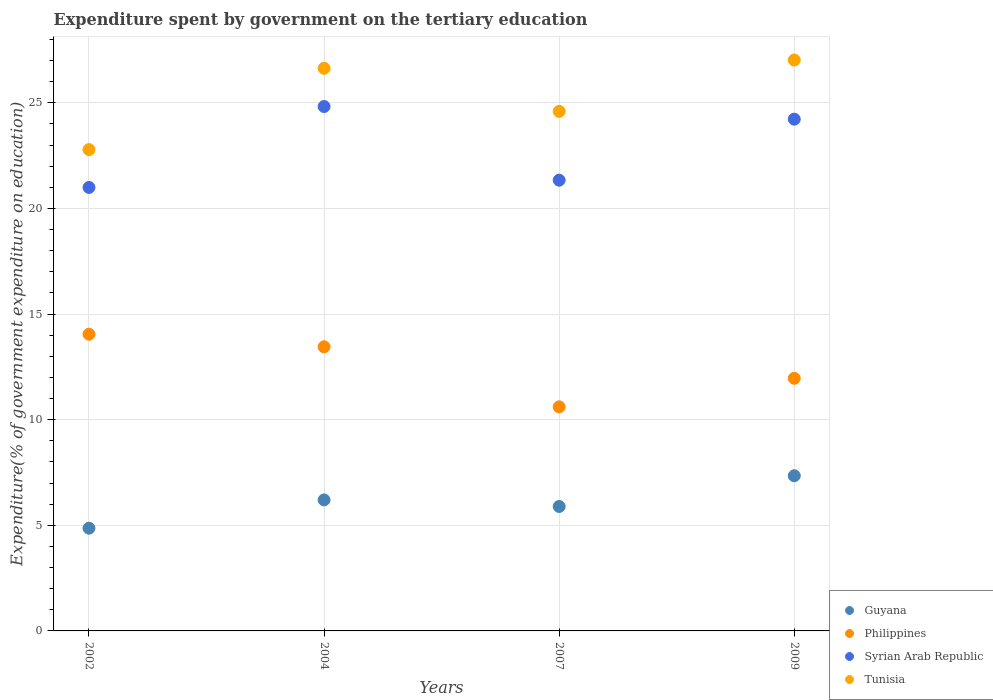How many different coloured dotlines are there?
Ensure brevity in your answer.  4. Is the number of dotlines equal to the number of legend labels?
Provide a succinct answer. Yes. What is the expenditure spent by government on the tertiary education in Philippines in 2002?
Offer a very short reply. 14.05. Across all years, what is the maximum expenditure spent by government on the tertiary education in Philippines?
Offer a very short reply. 14.05. Across all years, what is the minimum expenditure spent by government on the tertiary education in Philippines?
Keep it short and to the point. 10.61. What is the total expenditure spent by government on the tertiary education in Tunisia in the graph?
Keep it short and to the point. 101.03. What is the difference between the expenditure spent by government on the tertiary education in Tunisia in 2002 and that in 2004?
Your answer should be very brief. -3.85. What is the difference between the expenditure spent by government on the tertiary education in Tunisia in 2002 and the expenditure spent by government on the tertiary education in Syrian Arab Republic in 2009?
Provide a short and direct response. -1.44. What is the average expenditure spent by government on the tertiary education in Tunisia per year?
Your response must be concise. 25.26. In the year 2002, what is the difference between the expenditure spent by government on the tertiary education in Guyana and expenditure spent by government on the tertiary education in Philippines?
Ensure brevity in your answer.  -9.18. In how many years, is the expenditure spent by government on the tertiary education in Syrian Arab Republic greater than 16 %?
Make the answer very short. 4. What is the ratio of the expenditure spent by government on the tertiary education in Tunisia in 2002 to that in 2007?
Your answer should be very brief. 0.93. Is the difference between the expenditure spent by government on the tertiary education in Guyana in 2007 and 2009 greater than the difference between the expenditure spent by government on the tertiary education in Philippines in 2007 and 2009?
Ensure brevity in your answer.  No. What is the difference between the highest and the second highest expenditure spent by government on the tertiary education in Guyana?
Offer a very short reply. 1.14. What is the difference between the highest and the lowest expenditure spent by government on the tertiary education in Tunisia?
Your response must be concise. 4.24. In how many years, is the expenditure spent by government on the tertiary education in Philippines greater than the average expenditure spent by government on the tertiary education in Philippines taken over all years?
Offer a very short reply. 2. Is the sum of the expenditure spent by government on the tertiary education in Philippines in 2002 and 2007 greater than the maximum expenditure spent by government on the tertiary education in Tunisia across all years?
Keep it short and to the point. No. Is the expenditure spent by government on the tertiary education in Guyana strictly less than the expenditure spent by government on the tertiary education in Syrian Arab Republic over the years?
Your response must be concise. Yes. How many dotlines are there?
Your response must be concise. 4. Are the values on the major ticks of Y-axis written in scientific E-notation?
Offer a terse response. No. Does the graph contain grids?
Offer a terse response. Yes. How are the legend labels stacked?
Your answer should be compact. Vertical. What is the title of the graph?
Offer a very short reply. Expenditure spent by government on the tertiary education. Does "Burkina Faso" appear as one of the legend labels in the graph?
Offer a terse response. No. What is the label or title of the Y-axis?
Keep it short and to the point. Expenditure(% of government expenditure on education). What is the Expenditure(% of government expenditure on education) of Guyana in 2002?
Give a very brief answer. 4.86. What is the Expenditure(% of government expenditure on education) in Philippines in 2002?
Provide a succinct answer. 14.05. What is the Expenditure(% of government expenditure on education) of Syrian Arab Republic in 2002?
Your response must be concise. 20.99. What is the Expenditure(% of government expenditure on education) in Tunisia in 2002?
Provide a short and direct response. 22.78. What is the Expenditure(% of government expenditure on education) in Guyana in 2004?
Offer a terse response. 6.2. What is the Expenditure(% of government expenditure on education) of Philippines in 2004?
Ensure brevity in your answer.  13.45. What is the Expenditure(% of government expenditure on education) in Syrian Arab Republic in 2004?
Your answer should be very brief. 24.82. What is the Expenditure(% of government expenditure on education) of Tunisia in 2004?
Your answer should be very brief. 26.63. What is the Expenditure(% of government expenditure on education) of Guyana in 2007?
Provide a succinct answer. 5.89. What is the Expenditure(% of government expenditure on education) of Philippines in 2007?
Provide a succinct answer. 10.61. What is the Expenditure(% of government expenditure on education) of Syrian Arab Republic in 2007?
Provide a succinct answer. 21.34. What is the Expenditure(% of government expenditure on education) in Tunisia in 2007?
Provide a short and direct response. 24.59. What is the Expenditure(% of government expenditure on education) of Guyana in 2009?
Offer a very short reply. 7.34. What is the Expenditure(% of government expenditure on education) of Philippines in 2009?
Provide a short and direct response. 11.96. What is the Expenditure(% of government expenditure on education) of Syrian Arab Republic in 2009?
Keep it short and to the point. 24.22. What is the Expenditure(% of government expenditure on education) of Tunisia in 2009?
Provide a short and direct response. 27.02. Across all years, what is the maximum Expenditure(% of government expenditure on education) of Guyana?
Your answer should be compact. 7.34. Across all years, what is the maximum Expenditure(% of government expenditure on education) of Philippines?
Offer a very short reply. 14.05. Across all years, what is the maximum Expenditure(% of government expenditure on education) in Syrian Arab Republic?
Your response must be concise. 24.82. Across all years, what is the maximum Expenditure(% of government expenditure on education) in Tunisia?
Your answer should be compact. 27.02. Across all years, what is the minimum Expenditure(% of government expenditure on education) of Guyana?
Your answer should be very brief. 4.86. Across all years, what is the minimum Expenditure(% of government expenditure on education) in Philippines?
Offer a terse response. 10.61. Across all years, what is the minimum Expenditure(% of government expenditure on education) of Syrian Arab Republic?
Provide a succinct answer. 20.99. Across all years, what is the minimum Expenditure(% of government expenditure on education) in Tunisia?
Keep it short and to the point. 22.78. What is the total Expenditure(% of government expenditure on education) of Guyana in the graph?
Make the answer very short. 24.3. What is the total Expenditure(% of government expenditure on education) in Philippines in the graph?
Make the answer very short. 50.06. What is the total Expenditure(% of government expenditure on education) of Syrian Arab Republic in the graph?
Your answer should be compact. 91.37. What is the total Expenditure(% of government expenditure on education) in Tunisia in the graph?
Ensure brevity in your answer.  101.03. What is the difference between the Expenditure(% of government expenditure on education) of Guyana in 2002 and that in 2004?
Provide a short and direct response. -1.34. What is the difference between the Expenditure(% of government expenditure on education) in Philippines in 2002 and that in 2004?
Make the answer very short. 0.6. What is the difference between the Expenditure(% of government expenditure on education) of Syrian Arab Republic in 2002 and that in 2004?
Your answer should be very brief. -3.83. What is the difference between the Expenditure(% of government expenditure on education) in Tunisia in 2002 and that in 2004?
Offer a very short reply. -3.85. What is the difference between the Expenditure(% of government expenditure on education) in Guyana in 2002 and that in 2007?
Your answer should be compact. -1.03. What is the difference between the Expenditure(% of government expenditure on education) of Philippines in 2002 and that in 2007?
Make the answer very short. 3.44. What is the difference between the Expenditure(% of government expenditure on education) in Syrian Arab Republic in 2002 and that in 2007?
Provide a succinct answer. -0.34. What is the difference between the Expenditure(% of government expenditure on education) in Tunisia in 2002 and that in 2007?
Make the answer very short. -1.81. What is the difference between the Expenditure(% of government expenditure on education) of Guyana in 2002 and that in 2009?
Offer a terse response. -2.48. What is the difference between the Expenditure(% of government expenditure on education) in Philippines in 2002 and that in 2009?
Your answer should be very brief. 2.09. What is the difference between the Expenditure(% of government expenditure on education) in Syrian Arab Republic in 2002 and that in 2009?
Give a very brief answer. -3.23. What is the difference between the Expenditure(% of government expenditure on education) in Tunisia in 2002 and that in 2009?
Offer a very short reply. -4.24. What is the difference between the Expenditure(% of government expenditure on education) in Guyana in 2004 and that in 2007?
Provide a succinct answer. 0.31. What is the difference between the Expenditure(% of government expenditure on education) in Philippines in 2004 and that in 2007?
Provide a succinct answer. 2.84. What is the difference between the Expenditure(% of government expenditure on education) in Syrian Arab Republic in 2004 and that in 2007?
Offer a terse response. 3.49. What is the difference between the Expenditure(% of government expenditure on education) in Tunisia in 2004 and that in 2007?
Provide a short and direct response. 2.04. What is the difference between the Expenditure(% of government expenditure on education) of Guyana in 2004 and that in 2009?
Ensure brevity in your answer.  -1.14. What is the difference between the Expenditure(% of government expenditure on education) in Philippines in 2004 and that in 2009?
Provide a succinct answer. 1.49. What is the difference between the Expenditure(% of government expenditure on education) in Syrian Arab Republic in 2004 and that in 2009?
Provide a short and direct response. 0.6. What is the difference between the Expenditure(% of government expenditure on education) in Tunisia in 2004 and that in 2009?
Your answer should be compact. -0.39. What is the difference between the Expenditure(% of government expenditure on education) of Guyana in 2007 and that in 2009?
Ensure brevity in your answer.  -1.45. What is the difference between the Expenditure(% of government expenditure on education) of Philippines in 2007 and that in 2009?
Offer a very short reply. -1.35. What is the difference between the Expenditure(% of government expenditure on education) in Syrian Arab Republic in 2007 and that in 2009?
Provide a succinct answer. -2.89. What is the difference between the Expenditure(% of government expenditure on education) in Tunisia in 2007 and that in 2009?
Offer a very short reply. -2.43. What is the difference between the Expenditure(% of government expenditure on education) of Guyana in 2002 and the Expenditure(% of government expenditure on education) of Philippines in 2004?
Your response must be concise. -8.59. What is the difference between the Expenditure(% of government expenditure on education) of Guyana in 2002 and the Expenditure(% of government expenditure on education) of Syrian Arab Republic in 2004?
Keep it short and to the point. -19.96. What is the difference between the Expenditure(% of government expenditure on education) of Guyana in 2002 and the Expenditure(% of government expenditure on education) of Tunisia in 2004?
Provide a short and direct response. -21.77. What is the difference between the Expenditure(% of government expenditure on education) of Philippines in 2002 and the Expenditure(% of government expenditure on education) of Syrian Arab Republic in 2004?
Provide a succinct answer. -10.78. What is the difference between the Expenditure(% of government expenditure on education) of Philippines in 2002 and the Expenditure(% of government expenditure on education) of Tunisia in 2004?
Provide a succinct answer. -12.59. What is the difference between the Expenditure(% of government expenditure on education) of Syrian Arab Republic in 2002 and the Expenditure(% of government expenditure on education) of Tunisia in 2004?
Your answer should be very brief. -5.64. What is the difference between the Expenditure(% of government expenditure on education) of Guyana in 2002 and the Expenditure(% of government expenditure on education) of Philippines in 2007?
Provide a short and direct response. -5.74. What is the difference between the Expenditure(% of government expenditure on education) in Guyana in 2002 and the Expenditure(% of government expenditure on education) in Syrian Arab Republic in 2007?
Ensure brevity in your answer.  -16.47. What is the difference between the Expenditure(% of government expenditure on education) of Guyana in 2002 and the Expenditure(% of government expenditure on education) of Tunisia in 2007?
Provide a succinct answer. -19.73. What is the difference between the Expenditure(% of government expenditure on education) in Philippines in 2002 and the Expenditure(% of government expenditure on education) in Syrian Arab Republic in 2007?
Ensure brevity in your answer.  -7.29. What is the difference between the Expenditure(% of government expenditure on education) in Philippines in 2002 and the Expenditure(% of government expenditure on education) in Tunisia in 2007?
Provide a succinct answer. -10.55. What is the difference between the Expenditure(% of government expenditure on education) of Syrian Arab Republic in 2002 and the Expenditure(% of government expenditure on education) of Tunisia in 2007?
Keep it short and to the point. -3.6. What is the difference between the Expenditure(% of government expenditure on education) of Guyana in 2002 and the Expenditure(% of government expenditure on education) of Philippines in 2009?
Your answer should be compact. -7.09. What is the difference between the Expenditure(% of government expenditure on education) in Guyana in 2002 and the Expenditure(% of government expenditure on education) in Syrian Arab Republic in 2009?
Provide a succinct answer. -19.36. What is the difference between the Expenditure(% of government expenditure on education) of Guyana in 2002 and the Expenditure(% of government expenditure on education) of Tunisia in 2009?
Provide a succinct answer. -22.16. What is the difference between the Expenditure(% of government expenditure on education) of Philippines in 2002 and the Expenditure(% of government expenditure on education) of Syrian Arab Republic in 2009?
Your answer should be compact. -10.18. What is the difference between the Expenditure(% of government expenditure on education) of Philippines in 2002 and the Expenditure(% of government expenditure on education) of Tunisia in 2009?
Give a very brief answer. -12.98. What is the difference between the Expenditure(% of government expenditure on education) of Syrian Arab Republic in 2002 and the Expenditure(% of government expenditure on education) of Tunisia in 2009?
Your answer should be very brief. -6.03. What is the difference between the Expenditure(% of government expenditure on education) of Guyana in 2004 and the Expenditure(% of government expenditure on education) of Philippines in 2007?
Keep it short and to the point. -4.41. What is the difference between the Expenditure(% of government expenditure on education) in Guyana in 2004 and the Expenditure(% of government expenditure on education) in Syrian Arab Republic in 2007?
Offer a terse response. -15.13. What is the difference between the Expenditure(% of government expenditure on education) in Guyana in 2004 and the Expenditure(% of government expenditure on education) in Tunisia in 2007?
Provide a short and direct response. -18.39. What is the difference between the Expenditure(% of government expenditure on education) of Philippines in 2004 and the Expenditure(% of government expenditure on education) of Syrian Arab Republic in 2007?
Your answer should be very brief. -7.89. What is the difference between the Expenditure(% of government expenditure on education) of Philippines in 2004 and the Expenditure(% of government expenditure on education) of Tunisia in 2007?
Make the answer very short. -11.14. What is the difference between the Expenditure(% of government expenditure on education) in Syrian Arab Republic in 2004 and the Expenditure(% of government expenditure on education) in Tunisia in 2007?
Provide a succinct answer. 0.23. What is the difference between the Expenditure(% of government expenditure on education) in Guyana in 2004 and the Expenditure(% of government expenditure on education) in Philippines in 2009?
Provide a succinct answer. -5.76. What is the difference between the Expenditure(% of government expenditure on education) of Guyana in 2004 and the Expenditure(% of government expenditure on education) of Syrian Arab Republic in 2009?
Ensure brevity in your answer.  -18.02. What is the difference between the Expenditure(% of government expenditure on education) of Guyana in 2004 and the Expenditure(% of government expenditure on education) of Tunisia in 2009?
Your answer should be very brief. -20.82. What is the difference between the Expenditure(% of government expenditure on education) of Philippines in 2004 and the Expenditure(% of government expenditure on education) of Syrian Arab Republic in 2009?
Keep it short and to the point. -10.77. What is the difference between the Expenditure(% of government expenditure on education) in Philippines in 2004 and the Expenditure(% of government expenditure on education) in Tunisia in 2009?
Give a very brief answer. -13.58. What is the difference between the Expenditure(% of government expenditure on education) of Syrian Arab Republic in 2004 and the Expenditure(% of government expenditure on education) of Tunisia in 2009?
Your answer should be compact. -2.2. What is the difference between the Expenditure(% of government expenditure on education) of Guyana in 2007 and the Expenditure(% of government expenditure on education) of Philippines in 2009?
Your answer should be very brief. -6.07. What is the difference between the Expenditure(% of government expenditure on education) in Guyana in 2007 and the Expenditure(% of government expenditure on education) in Syrian Arab Republic in 2009?
Provide a succinct answer. -18.33. What is the difference between the Expenditure(% of government expenditure on education) of Guyana in 2007 and the Expenditure(% of government expenditure on education) of Tunisia in 2009?
Offer a terse response. -21.13. What is the difference between the Expenditure(% of government expenditure on education) in Philippines in 2007 and the Expenditure(% of government expenditure on education) in Syrian Arab Republic in 2009?
Make the answer very short. -13.62. What is the difference between the Expenditure(% of government expenditure on education) of Philippines in 2007 and the Expenditure(% of government expenditure on education) of Tunisia in 2009?
Provide a short and direct response. -16.42. What is the difference between the Expenditure(% of government expenditure on education) in Syrian Arab Republic in 2007 and the Expenditure(% of government expenditure on education) in Tunisia in 2009?
Provide a succinct answer. -5.69. What is the average Expenditure(% of government expenditure on education) in Guyana per year?
Your answer should be very brief. 6.07. What is the average Expenditure(% of government expenditure on education) of Philippines per year?
Give a very brief answer. 12.51. What is the average Expenditure(% of government expenditure on education) in Syrian Arab Republic per year?
Your response must be concise. 22.84. What is the average Expenditure(% of government expenditure on education) in Tunisia per year?
Your answer should be compact. 25.26. In the year 2002, what is the difference between the Expenditure(% of government expenditure on education) of Guyana and Expenditure(% of government expenditure on education) of Philippines?
Ensure brevity in your answer.  -9.18. In the year 2002, what is the difference between the Expenditure(% of government expenditure on education) of Guyana and Expenditure(% of government expenditure on education) of Syrian Arab Republic?
Keep it short and to the point. -16.13. In the year 2002, what is the difference between the Expenditure(% of government expenditure on education) of Guyana and Expenditure(% of government expenditure on education) of Tunisia?
Ensure brevity in your answer.  -17.92. In the year 2002, what is the difference between the Expenditure(% of government expenditure on education) of Philippines and Expenditure(% of government expenditure on education) of Syrian Arab Republic?
Your answer should be very brief. -6.95. In the year 2002, what is the difference between the Expenditure(% of government expenditure on education) of Philippines and Expenditure(% of government expenditure on education) of Tunisia?
Offer a very short reply. -8.74. In the year 2002, what is the difference between the Expenditure(% of government expenditure on education) in Syrian Arab Republic and Expenditure(% of government expenditure on education) in Tunisia?
Provide a short and direct response. -1.79. In the year 2004, what is the difference between the Expenditure(% of government expenditure on education) of Guyana and Expenditure(% of government expenditure on education) of Philippines?
Your answer should be very brief. -7.25. In the year 2004, what is the difference between the Expenditure(% of government expenditure on education) of Guyana and Expenditure(% of government expenditure on education) of Syrian Arab Republic?
Your response must be concise. -18.62. In the year 2004, what is the difference between the Expenditure(% of government expenditure on education) of Guyana and Expenditure(% of government expenditure on education) of Tunisia?
Your response must be concise. -20.43. In the year 2004, what is the difference between the Expenditure(% of government expenditure on education) of Philippines and Expenditure(% of government expenditure on education) of Syrian Arab Republic?
Your answer should be compact. -11.37. In the year 2004, what is the difference between the Expenditure(% of government expenditure on education) in Philippines and Expenditure(% of government expenditure on education) in Tunisia?
Provide a succinct answer. -13.18. In the year 2004, what is the difference between the Expenditure(% of government expenditure on education) in Syrian Arab Republic and Expenditure(% of government expenditure on education) in Tunisia?
Offer a terse response. -1.81. In the year 2007, what is the difference between the Expenditure(% of government expenditure on education) of Guyana and Expenditure(% of government expenditure on education) of Philippines?
Your answer should be very brief. -4.72. In the year 2007, what is the difference between the Expenditure(% of government expenditure on education) in Guyana and Expenditure(% of government expenditure on education) in Syrian Arab Republic?
Give a very brief answer. -15.45. In the year 2007, what is the difference between the Expenditure(% of government expenditure on education) of Guyana and Expenditure(% of government expenditure on education) of Tunisia?
Provide a succinct answer. -18.7. In the year 2007, what is the difference between the Expenditure(% of government expenditure on education) of Philippines and Expenditure(% of government expenditure on education) of Syrian Arab Republic?
Your answer should be compact. -10.73. In the year 2007, what is the difference between the Expenditure(% of government expenditure on education) in Philippines and Expenditure(% of government expenditure on education) in Tunisia?
Keep it short and to the point. -13.98. In the year 2007, what is the difference between the Expenditure(% of government expenditure on education) in Syrian Arab Republic and Expenditure(% of government expenditure on education) in Tunisia?
Provide a succinct answer. -3.26. In the year 2009, what is the difference between the Expenditure(% of government expenditure on education) in Guyana and Expenditure(% of government expenditure on education) in Philippines?
Offer a terse response. -4.61. In the year 2009, what is the difference between the Expenditure(% of government expenditure on education) in Guyana and Expenditure(% of government expenditure on education) in Syrian Arab Republic?
Provide a short and direct response. -16.88. In the year 2009, what is the difference between the Expenditure(% of government expenditure on education) of Guyana and Expenditure(% of government expenditure on education) of Tunisia?
Offer a terse response. -19.68. In the year 2009, what is the difference between the Expenditure(% of government expenditure on education) in Philippines and Expenditure(% of government expenditure on education) in Syrian Arab Republic?
Your answer should be very brief. -12.27. In the year 2009, what is the difference between the Expenditure(% of government expenditure on education) of Philippines and Expenditure(% of government expenditure on education) of Tunisia?
Offer a very short reply. -15.07. In the year 2009, what is the difference between the Expenditure(% of government expenditure on education) of Syrian Arab Republic and Expenditure(% of government expenditure on education) of Tunisia?
Offer a terse response. -2.8. What is the ratio of the Expenditure(% of government expenditure on education) in Guyana in 2002 to that in 2004?
Offer a terse response. 0.78. What is the ratio of the Expenditure(% of government expenditure on education) of Philippines in 2002 to that in 2004?
Your answer should be compact. 1.04. What is the ratio of the Expenditure(% of government expenditure on education) in Syrian Arab Republic in 2002 to that in 2004?
Ensure brevity in your answer.  0.85. What is the ratio of the Expenditure(% of government expenditure on education) of Tunisia in 2002 to that in 2004?
Your response must be concise. 0.86. What is the ratio of the Expenditure(% of government expenditure on education) in Guyana in 2002 to that in 2007?
Provide a succinct answer. 0.83. What is the ratio of the Expenditure(% of government expenditure on education) in Philippines in 2002 to that in 2007?
Offer a terse response. 1.32. What is the ratio of the Expenditure(% of government expenditure on education) in Syrian Arab Republic in 2002 to that in 2007?
Your response must be concise. 0.98. What is the ratio of the Expenditure(% of government expenditure on education) in Tunisia in 2002 to that in 2007?
Your answer should be very brief. 0.93. What is the ratio of the Expenditure(% of government expenditure on education) in Guyana in 2002 to that in 2009?
Your answer should be compact. 0.66. What is the ratio of the Expenditure(% of government expenditure on education) in Philippines in 2002 to that in 2009?
Your answer should be very brief. 1.17. What is the ratio of the Expenditure(% of government expenditure on education) in Syrian Arab Republic in 2002 to that in 2009?
Make the answer very short. 0.87. What is the ratio of the Expenditure(% of government expenditure on education) in Tunisia in 2002 to that in 2009?
Your answer should be very brief. 0.84. What is the ratio of the Expenditure(% of government expenditure on education) of Guyana in 2004 to that in 2007?
Offer a terse response. 1.05. What is the ratio of the Expenditure(% of government expenditure on education) in Philippines in 2004 to that in 2007?
Your answer should be very brief. 1.27. What is the ratio of the Expenditure(% of government expenditure on education) in Syrian Arab Republic in 2004 to that in 2007?
Keep it short and to the point. 1.16. What is the ratio of the Expenditure(% of government expenditure on education) in Tunisia in 2004 to that in 2007?
Your answer should be very brief. 1.08. What is the ratio of the Expenditure(% of government expenditure on education) in Guyana in 2004 to that in 2009?
Provide a succinct answer. 0.84. What is the ratio of the Expenditure(% of government expenditure on education) of Philippines in 2004 to that in 2009?
Your answer should be compact. 1.12. What is the ratio of the Expenditure(% of government expenditure on education) in Syrian Arab Republic in 2004 to that in 2009?
Give a very brief answer. 1.02. What is the ratio of the Expenditure(% of government expenditure on education) in Tunisia in 2004 to that in 2009?
Give a very brief answer. 0.99. What is the ratio of the Expenditure(% of government expenditure on education) of Guyana in 2007 to that in 2009?
Offer a very short reply. 0.8. What is the ratio of the Expenditure(% of government expenditure on education) in Philippines in 2007 to that in 2009?
Your response must be concise. 0.89. What is the ratio of the Expenditure(% of government expenditure on education) in Syrian Arab Republic in 2007 to that in 2009?
Your response must be concise. 0.88. What is the ratio of the Expenditure(% of government expenditure on education) of Tunisia in 2007 to that in 2009?
Provide a short and direct response. 0.91. What is the difference between the highest and the second highest Expenditure(% of government expenditure on education) of Guyana?
Keep it short and to the point. 1.14. What is the difference between the highest and the second highest Expenditure(% of government expenditure on education) of Philippines?
Keep it short and to the point. 0.6. What is the difference between the highest and the second highest Expenditure(% of government expenditure on education) in Syrian Arab Republic?
Offer a very short reply. 0.6. What is the difference between the highest and the second highest Expenditure(% of government expenditure on education) of Tunisia?
Provide a short and direct response. 0.39. What is the difference between the highest and the lowest Expenditure(% of government expenditure on education) of Guyana?
Provide a succinct answer. 2.48. What is the difference between the highest and the lowest Expenditure(% of government expenditure on education) in Philippines?
Make the answer very short. 3.44. What is the difference between the highest and the lowest Expenditure(% of government expenditure on education) of Syrian Arab Republic?
Make the answer very short. 3.83. What is the difference between the highest and the lowest Expenditure(% of government expenditure on education) in Tunisia?
Your answer should be compact. 4.24. 